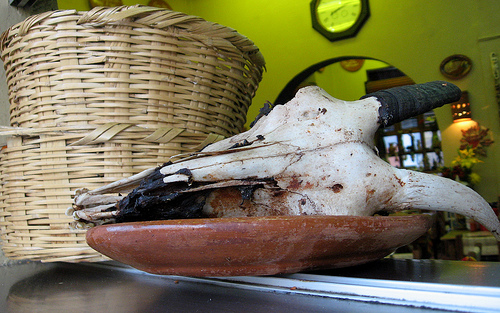<image>
Can you confirm if the skull is to the right of the basket? Yes. From this viewpoint, the skull is positioned to the right side relative to the basket. 